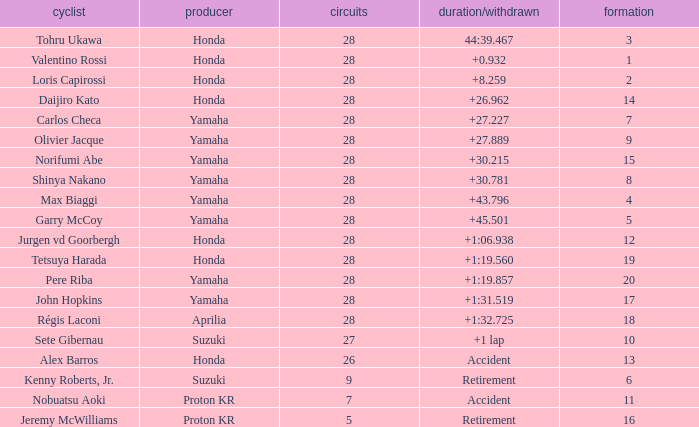How many laps did pere riba ride? 28.0. I'm looking to parse the entire table for insights. Could you assist me with that? {'header': ['cyclist', 'producer', 'circuits', 'duration/withdrawn', 'formation'], 'rows': [['Tohru Ukawa', 'Honda', '28', '44:39.467', '3'], ['Valentino Rossi', 'Honda', '28', '+0.932', '1'], ['Loris Capirossi', 'Honda', '28', '+8.259', '2'], ['Daijiro Kato', 'Honda', '28', '+26.962', '14'], ['Carlos Checa', 'Yamaha', '28', '+27.227', '7'], ['Olivier Jacque', 'Yamaha', '28', '+27.889', '9'], ['Norifumi Abe', 'Yamaha', '28', '+30.215', '15'], ['Shinya Nakano', 'Yamaha', '28', '+30.781', '8'], ['Max Biaggi', 'Yamaha', '28', '+43.796', '4'], ['Garry McCoy', 'Yamaha', '28', '+45.501', '5'], ['Jurgen vd Goorbergh', 'Honda', '28', '+1:06.938', '12'], ['Tetsuya Harada', 'Honda', '28', '+1:19.560', '19'], ['Pere Riba', 'Yamaha', '28', '+1:19.857', '20'], ['John Hopkins', 'Yamaha', '28', '+1:31.519', '17'], ['Régis Laconi', 'Aprilia', '28', '+1:32.725', '18'], ['Sete Gibernau', 'Suzuki', '27', '+1 lap', '10'], ['Alex Barros', 'Honda', '26', 'Accident', '13'], ['Kenny Roberts, Jr.', 'Suzuki', '9', 'Retirement', '6'], ['Nobuatsu Aoki', 'Proton KR', '7', 'Accident', '11'], ['Jeremy McWilliams', 'Proton KR', '5', 'Retirement', '16']]} 